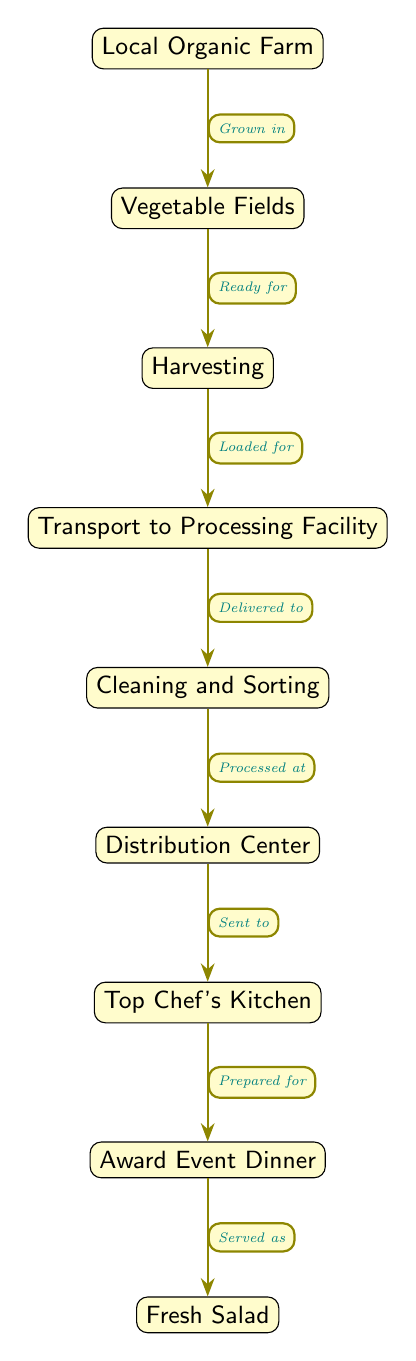What's the starting point of the food chain? The diagram begins with the node labeled "Local Organic Farm," which indicates that the food chain starts at the farm.
Answer: Local Organic Farm What is the final product served? The last node in the diagram is "Fresh Salad," indicating that this is the final product served at the event.
Answer: Fresh Salad How many nodes are there in total? Counting each labeled node in the diagram, including the initial farm and the final salad, there are eight nodes.
Answer: 8 What process occurs after harvesting? The diagram shows that after "Harvesting," the next step is "Transport to Processing Facility," indicating what comes next.
Answer: Transport to Processing Facility What is sent to the chef's kitchen? The diagram specifies that the node labeled "Distribution Center" sends the items to the "Top Chef's Kitchen," highlighting what is moved.
Answer: Top Chef's Kitchen Which node is associated with preparation? The diagram indicates that the node "Top Chef's Kitchen" is where the salad is prepared for the "Award Event Dinner," showing its role in the process.
Answer: Top Chef's Kitchen What is the relationship between the event and the fresh salad? The diagram indicates that at the "Award Event Dinner," the product served is the "Fresh Salad," establishing a direct connection between these two nodes.
Answer: Served as How does the salad reach the event dinner? Following the arrows in the diagram, the "Fresh Salad" is prepared by the chef for the "Award Event Dinner," showing the flow from preparation to serving.
Answer: Prepared for 